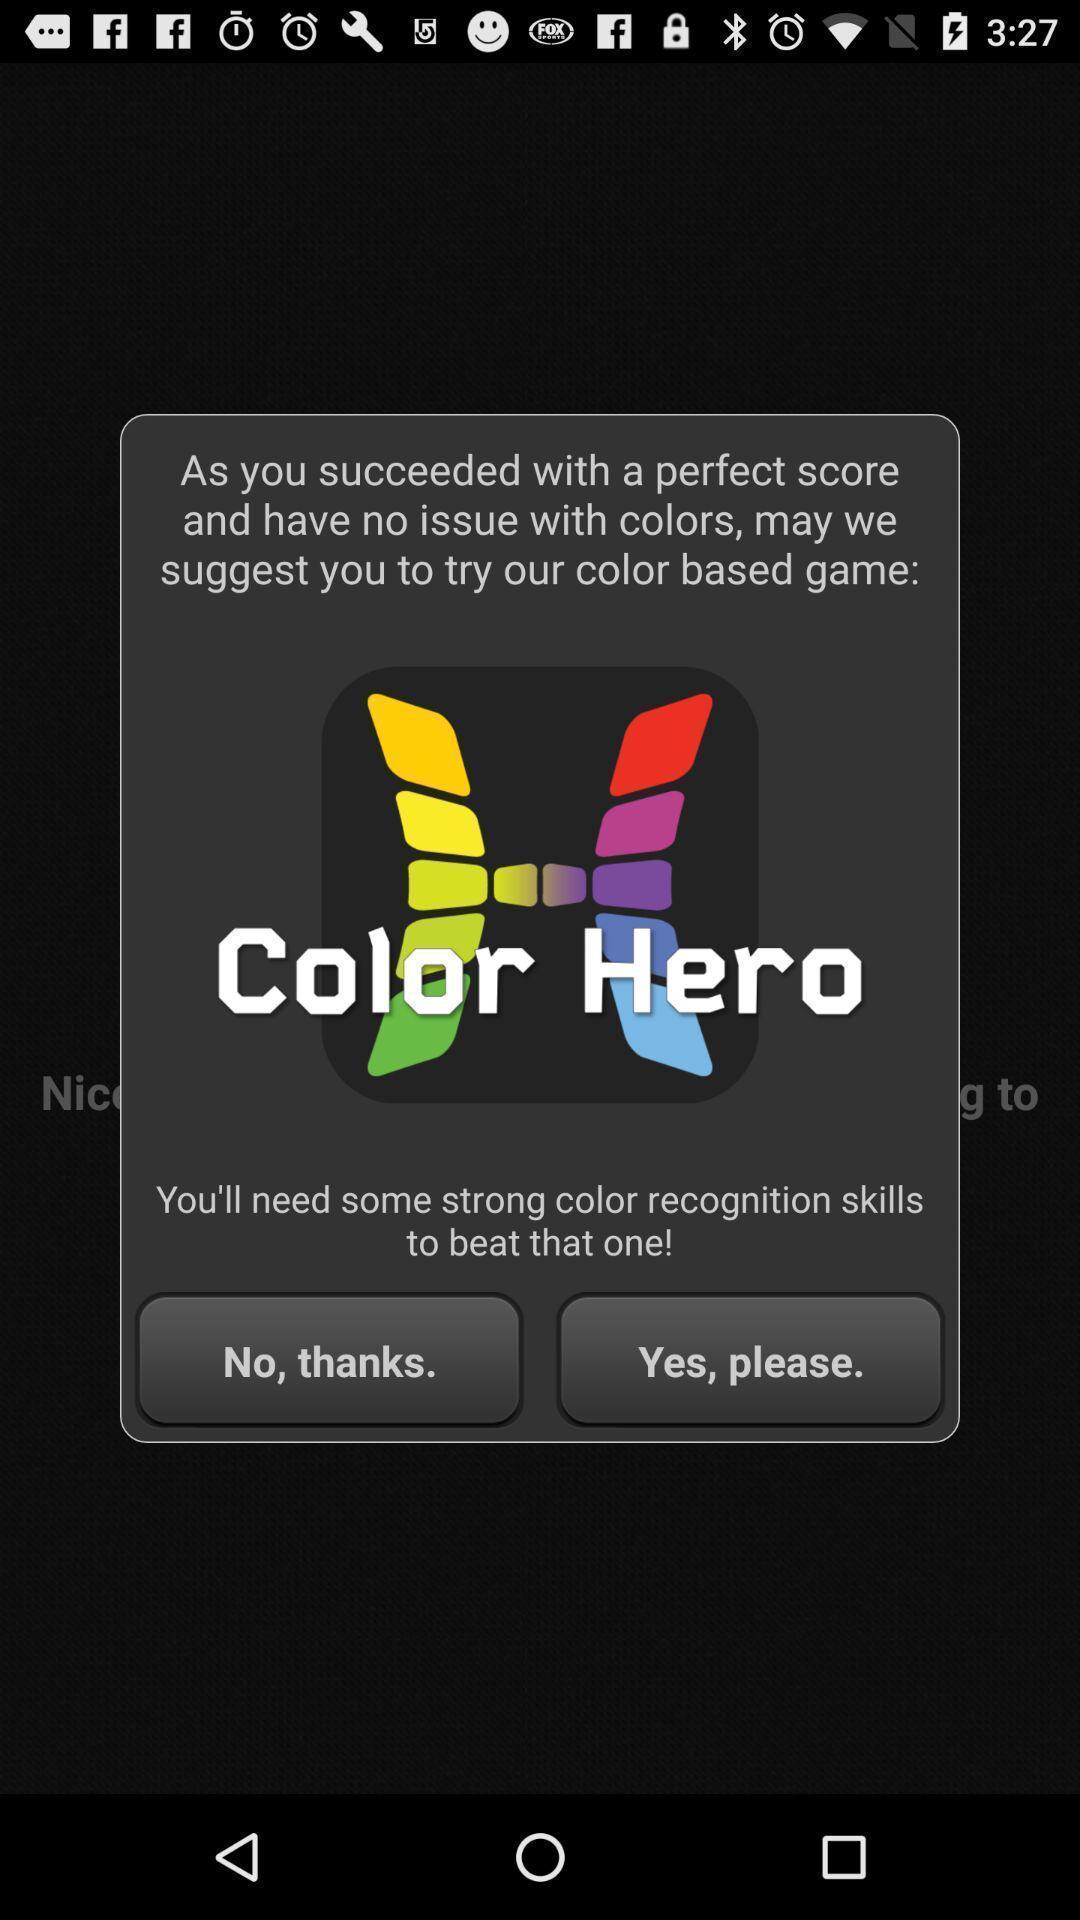Give me a narrative description of this picture. Pop-up displaying information about application with other options. 